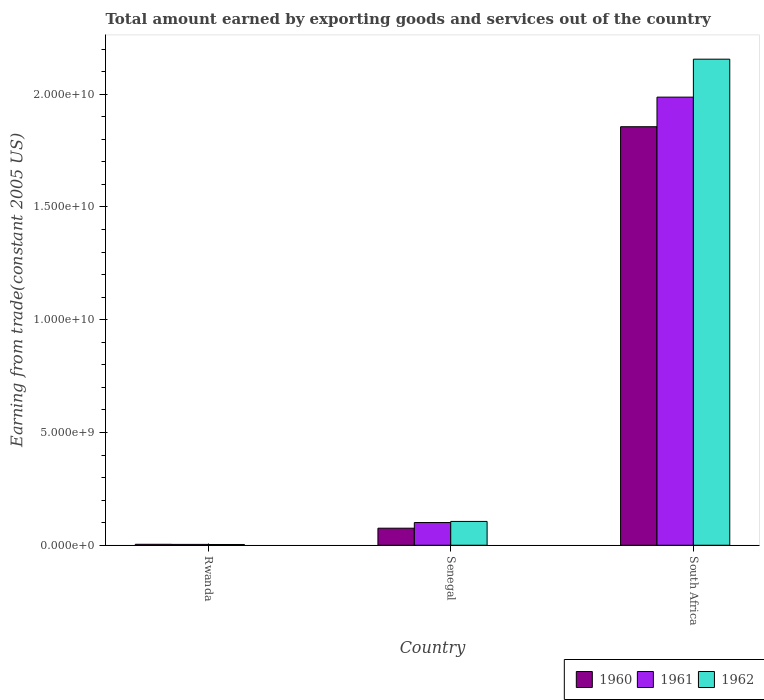Are the number of bars on each tick of the X-axis equal?
Keep it short and to the point. Yes. How many bars are there on the 2nd tick from the right?
Ensure brevity in your answer.  3. What is the label of the 3rd group of bars from the left?
Give a very brief answer. South Africa. In how many cases, is the number of bars for a given country not equal to the number of legend labels?
Your response must be concise. 0. What is the total amount earned by exporting goods and services in 1960 in South Africa?
Offer a very short reply. 1.86e+1. Across all countries, what is the maximum total amount earned by exporting goods and services in 1961?
Your response must be concise. 1.99e+1. Across all countries, what is the minimum total amount earned by exporting goods and services in 1960?
Give a very brief answer. 4.18e+07. In which country was the total amount earned by exporting goods and services in 1962 maximum?
Offer a very short reply. South Africa. In which country was the total amount earned by exporting goods and services in 1960 minimum?
Your answer should be very brief. Rwanda. What is the total total amount earned by exporting goods and services in 1960 in the graph?
Offer a terse response. 1.94e+1. What is the difference between the total amount earned by exporting goods and services in 1960 in Rwanda and that in South Africa?
Your response must be concise. -1.85e+1. What is the difference between the total amount earned by exporting goods and services in 1961 in Rwanda and the total amount earned by exporting goods and services in 1962 in South Africa?
Offer a very short reply. -2.15e+1. What is the average total amount earned by exporting goods and services in 1962 per country?
Keep it short and to the point. 7.55e+09. What is the difference between the total amount earned by exporting goods and services of/in 1961 and total amount earned by exporting goods and services of/in 1960 in South Africa?
Provide a succinct answer. 1.31e+09. In how many countries, is the total amount earned by exporting goods and services in 1960 greater than 14000000000 US$?
Keep it short and to the point. 1. What is the ratio of the total amount earned by exporting goods and services in 1962 in Senegal to that in South Africa?
Your response must be concise. 0.05. Is the total amount earned by exporting goods and services in 1962 in Rwanda less than that in South Africa?
Your answer should be very brief. Yes. Is the difference between the total amount earned by exporting goods and services in 1961 in Senegal and South Africa greater than the difference between the total amount earned by exporting goods and services in 1960 in Senegal and South Africa?
Give a very brief answer. No. What is the difference between the highest and the second highest total amount earned by exporting goods and services in 1960?
Offer a very short reply. 1.78e+1. What is the difference between the highest and the lowest total amount earned by exporting goods and services in 1960?
Provide a short and direct response. 1.85e+1. What does the 3rd bar from the left in South Africa represents?
Provide a short and direct response. 1962. What does the 2nd bar from the right in Senegal represents?
Your answer should be very brief. 1961. Is it the case that in every country, the sum of the total amount earned by exporting goods and services in 1961 and total amount earned by exporting goods and services in 1960 is greater than the total amount earned by exporting goods and services in 1962?
Make the answer very short. Yes. How many bars are there?
Make the answer very short. 9. Are all the bars in the graph horizontal?
Offer a very short reply. No. Where does the legend appear in the graph?
Provide a short and direct response. Bottom right. What is the title of the graph?
Give a very brief answer. Total amount earned by exporting goods and services out of the country. Does "2011" appear as one of the legend labels in the graph?
Offer a very short reply. No. What is the label or title of the X-axis?
Offer a terse response. Country. What is the label or title of the Y-axis?
Your answer should be compact. Earning from trade(constant 2005 US). What is the Earning from trade(constant 2005 US) of 1960 in Rwanda?
Offer a terse response. 4.18e+07. What is the Earning from trade(constant 2005 US) of 1961 in Rwanda?
Make the answer very short. 3.69e+07. What is the Earning from trade(constant 2005 US) in 1962 in Rwanda?
Make the answer very short. 3.32e+07. What is the Earning from trade(constant 2005 US) in 1960 in Senegal?
Your answer should be very brief. 7.56e+08. What is the Earning from trade(constant 2005 US) in 1961 in Senegal?
Offer a terse response. 1.01e+09. What is the Earning from trade(constant 2005 US) of 1962 in Senegal?
Your response must be concise. 1.06e+09. What is the Earning from trade(constant 2005 US) in 1960 in South Africa?
Offer a very short reply. 1.86e+1. What is the Earning from trade(constant 2005 US) of 1961 in South Africa?
Your response must be concise. 1.99e+1. What is the Earning from trade(constant 2005 US) in 1962 in South Africa?
Keep it short and to the point. 2.16e+1. Across all countries, what is the maximum Earning from trade(constant 2005 US) of 1960?
Your answer should be very brief. 1.86e+1. Across all countries, what is the maximum Earning from trade(constant 2005 US) in 1961?
Offer a very short reply. 1.99e+1. Across all countries, what is the maximum Earning from trade(constant 2005 US) of 1962?
Provide a succinct answer. 2.16e+1. Across all countries, what is the minimum Earning from trade(constant 2005 US) in 1960?
Provide a short and direct response. 4.18e+07. Across all countries, what is the minimum Earning from trade(constant 2005 US) in 1961?
Provide a succinct answer. 3.69e+07. Across all countries, what is the minimum Earning from trade(constant 2005 US) in 1962?
Your response must be concise. 3.32e+07. What is the total Earning from trade(constant 2005 US) in 1960 in the graph?
Make the answer very short. 1.94e+1. What is the total Earning from trade(constant 2005 US) in 1961 in the graph?
Ensure brevity in your answer.  2.09e+1. What is the total Earning from trade(constant 2005 US) in 1962 in the graph?
Your answer should be very brief. 2.26e+1. What is the difference between the Earning from trade(constant 2005 US) in 1960 in Rwanda and that in Senegal?
Your answer should be compact. -7.14e+08. What is the difference between the Earning from trade(constant 2005 US) of 1961 in Rwanda and that in Senegal?
Your answer should be very brief. -9.70e+08. What is the difference between the Earning from trade(constant 2005 US) of 1962 in Rwanda and that in Senegal?
Make the answer very short. -1.02e+09. What is the difference between the Earning from trade(constant 2005 US) in 1960 in Rwanda and that in South Africa?
Offer a terse response. -1.85e+1. What is the difference between the Earning from trade(constant 2005 US) of 1961 in Rwanda and that in South Africa?
Offer a terse response. -1.98e+1. What is the difference between the Earning from trade(constant 2005 US) in 1962 in Rwanda and that in South Africa?
Your answer should be compact. -2.15e+1. What is the difference between the Earning from trade(constant 2005 US) of 1960 in Senegal and that in South Africa?
Your answer should be very brief. -1.78e+1. What is the difference between the Earning from trade(constant 2005 US) in 1961 in Senegal and that in South Africa?
Ensure brevity in your answer.  -1.89e+1. What is the difference between the Earning from trade(constant 2005 US) of 1962 in Senegal and that in South Africa?
Keep it short and to the point. -2.05e+1. What is the difference between the Earning from trade(constant 2005 US) of 1960 in Rwanda and the Earning from trade(constant 2005 US) of 1961 in Senegal?
Offer a terse response. -9.65e+08. What is the difference between the Earning from trade(constant 2005 US) of 1960 in Rwanda and the Earning from trade(constant 2005 US) of 1962 in Senegal?
Your answer should be very brief. -1.01e+09. What is the difference between the Earning from trade(constant 2005 US) in 1961 in Rwanda and the Earning from trade(constant 2005 US) in 1962 in Senegal?
Provide a succinct answer. -1.02e+09. What is the difference between the Earning from trade(constant 2005 US) of 1960 in Rwanda and the Earning from trade(constant 2005 US) of 1961 in South Africa?
Your response must be concise. -1.98e+1. What is the difference between the Earning from trade(constant 2005 US) of 1960 in Rwanda and the Earning from trade(constant 2005 US) of 1962 in South Africa?
Make the answer very short. -2.15e+1. What is the difference between the Earning from trade(constant 2005 US) in 1961 in Rwanda and the Earning from trade(constant 2005 US) in 1962 in South Africa?
Your answer should be very brief. -2.15e+1. What is the difference between the Earning from trade(constant 2005 US) in 1960 in Senegal and the Earning from trade(constant 2005 US) in 1961 in South Africa?
Keep it short and to the point. -1.91e+1. What is the difference between the Earning from trade(constant 2005 US) of 1960 in Senegal and the Earning from trade(constant 2005 US) of 1962 in South Africa?
Provide a succinct answer. -2.08e+1. What is the difference between the Earning from trade(constant 2005 US) of 1961 in Senegal and the Earning from trade(constant 2005 US) of 1962 in South Africa?
Offer a terse response. -2.05e+1. What is the average Earning from trade(constant 2005 US) of 1960 per country?
Keep it short and to the point. 6.45e+09. What is the average Earning from trade(constant 2005 US) of 1961 per country?
Ensure brevity in your answer.  6.97e+09. What is the average Earning from trade(constant 2005 US) of 1962 per country?
Offer a terse response. 7.55e+09. What is the difference between the Earning from trade(constant 2005 US) of 1960 and Earning from trade(constant 2005 US) of 1961 in Rwanda?
Ensure brevity in your answer.  4.89e+06. What is the difference between the Earning from trade(constant 2005 US) of 1960 and Earning from trade(constant 2005 US) of 1962 in Rwanda?
Provide a succinct answer. 8.56e+06. What is the difference between the Earning from trade(constant 2005 US) in 1961 and Earning from trade(constant 2005 US) in 1962 in Rwanda?
Make the answer very short. 3.68e+06. What is the difference between the Earning from trade(constant 2005 US) in 1960 and Earning from trade(constant 2005 US) in 1961 in Senegal?
Keep it short and to the point. -2.51e+08. What is the difference between the Earning from trade(constant 2005 US) in 1960 and Earning from trade(constant 2005 US) in 1962 in Senegal?
Make the answer very short. -3.00e+08. What is the difference between the Earning from trade(constant 2005 US) in 1961 and Earning from trade(constant 2005 US) in 1962 in Senegal?
Provide a succinct answer. -4.96e+07. What is the difference between the Earning from trade(constant 2005 US) of 1960 and Earning from trade(constant 2005 US) of 1961 in South Africa?
Keep it short and to the point. -1.31e+09. What is the difference between the Earning from trade(constant 2005 US) in 1960 and Earning from trade(constant 2005 US) in 1962 in South Africa?
Offer a very short reply. -3.00e+09. What is the difference between the Earning from trade(constant 2005 US) of 1961 and Earning from trade(constant 2005 US) of 1962 in South Africa?
Provide a succinct answer. -1.68e+09. What is the ratio of the Earning from trade(constant 2005 US) of 1960 in Rwanda to that in Senegal?
Your answer should be very brief. 0.06. What is the ratio of the Earning from trade(constant 2005 US) of 1961 in Rwanda to that in Senegal?
Your answer should be compact. 0.04. What is the ratio of the Earning from trade(constant 2005 US) of 1962 in Rwanda to that in Senegal?
Offer a terse response. 0.03. What is the ratio of the Earning from trade(constant 2005 US) in 1960 in Rwanda to that in South Africa?
Give a very brief answer. 0. What is the ratio of the Earning from trade(constant 2005 US) in 1961 in Rwanda to that in South Africa?
Keep it short and to the point. 0. What is the ratio of the Earning from trade(constant 2005 US) in 1962 in Rwanda to that in South Africa?
Keep it short and to the point. 0. What is the ratio of the Earning from trade(constant 2005 US) in 1960 in Senegal to that in South Africa?
Your answer should be very brief. 0.04. What is the ratio of the Earning from trade(constant 2005 US) in 1961 in Senegal to that in South Africa?
Provide a succinct answer. 0.05. What is the ratio of the Earning from trade(constant 2005 US) of 1962 in Senegal to that in South Africa?
Keep it short and to the point. 0.05. What is the difference between the highest and the second highest Earning from trade(constant 2005 US) of 1960?
Your answer should be compact. 1.78e+1. What is the difference between the highest and the second highest Earning from trade(constant 2005 US) in 1961?
Ensure brevity in your answer.  1.89e+1. What is the difference between the highest and the second highest Earning from trade(constant 2005 US) of 1962?
Your answer should be very brief. 2.05e+1. What is the difference between the highest and the lowest Earning from trade(constant 2005 US) of 1960?
Your response must be concise. 1.85e+1. What is the difference between the highest and the lowest Earning from trade(constant 2005 US) of 1961?
Make the answer very short. 1.98e+1. What is the difference between the highest and the lowest Earning from trade(constant 2005 US) in 1962?
Your answer should be compact. 2.15e+1. 